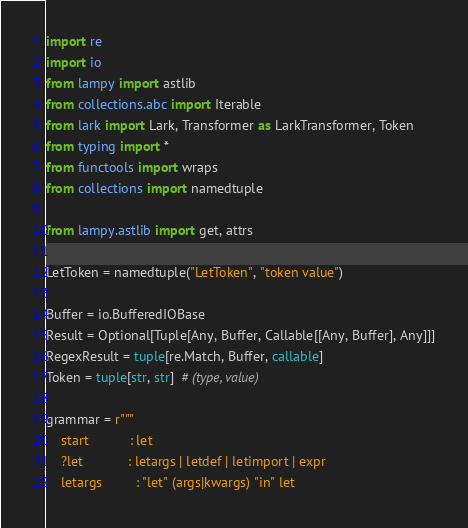Convert code to text. <code><loc_0><loc_0><loc_500><loc_500><_Python_>import re
import io
from lampy import astlib
from collections.abc import Iterable
from lark import Lark, Transformer as LarkTransformer, Token
from typing import *
from functools import wraps
from collections import namedtuple

from lampy.astlib import get, attrs

LetToken = namedtuple("LetToken", "token value")

Buffer = io.BufferedIOBase
Result = Optional[Tuple[Any, Buffer, Callable[[Any, Buffer], Any]]]
RegexResult = tuple[re.Match, Buffer, callable]
Token = tuple[str, str]  # (type, value)

grammar = r"""
    start           : let
    ?let            : letargs | letdef | letimport | expr
    letargs         : "let" (args|kwargs) "in" let</code> 